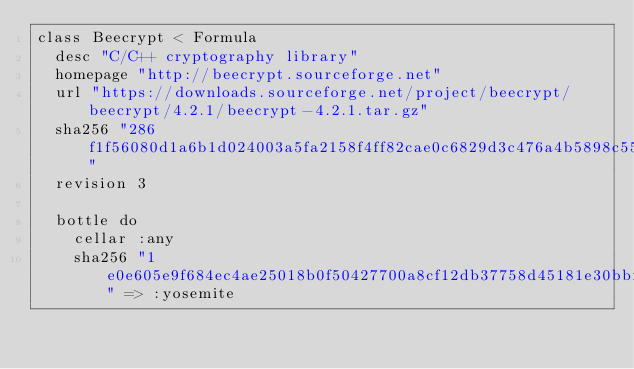<code> <loc_0><loc_0><loc_500><loc_500><_Ruby_>class Beecrypt < Formula
  desc "C/C++ cryptography library"
  homepage "http://beecrypt.sourceforge.net"
  url "https://downloads.sourceforge.net/project/beecrypt/beecrypt/4.2.1/beecrypt-4.2.1.tar.gz"
  sha256 "286f1f56080d1a6b1d024003a5fa2158f4ff82cae0c6829d3c476a4b5898c55d"
  revision 3

  bottle do
    cellar :any
    sha256 "1e0e605e9f684ec4ae25018b0f50427700a8cf12db37758d45181e30bbf1b151" => :yosemite</code> 